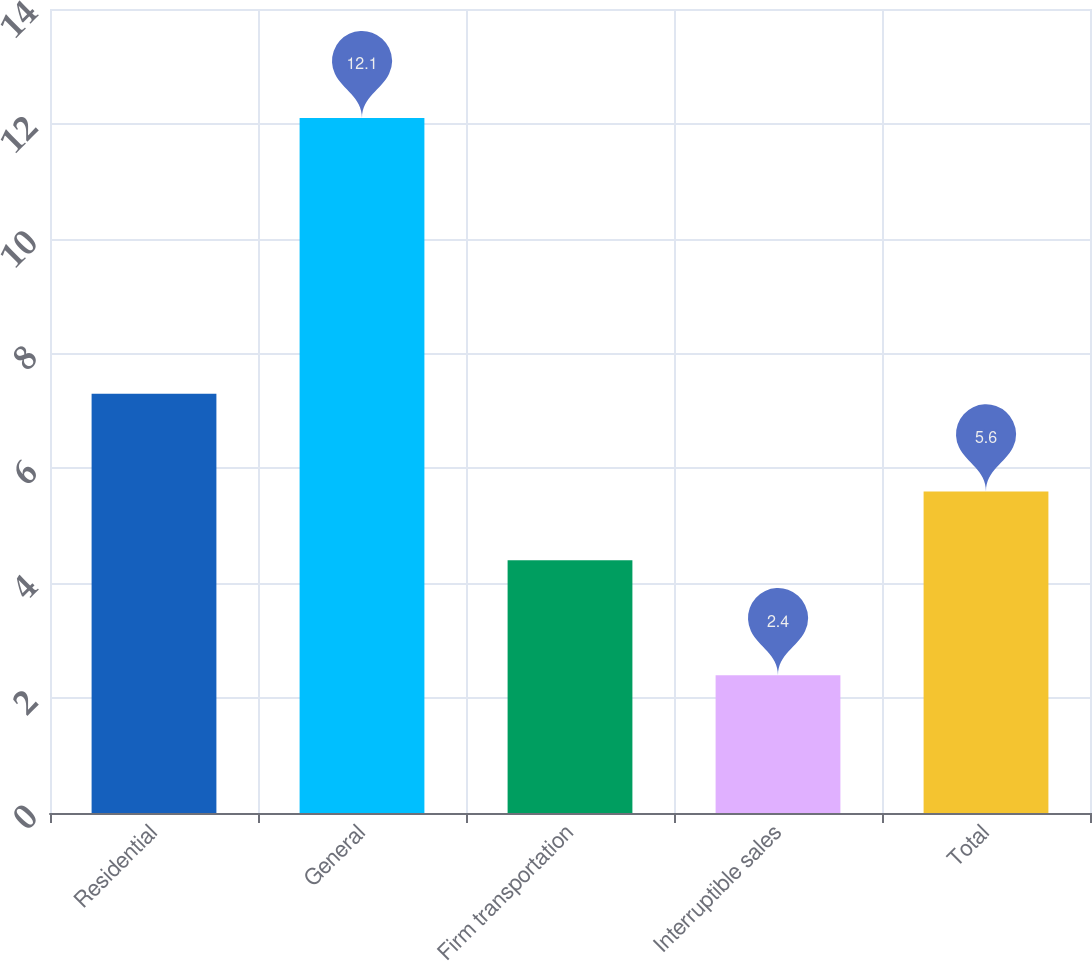Convert chart. <chart><loc_0><loc_0><loc_500><loc_500><bar_chart><fcel>Residential<fcel>General<fcel>Firm transportation<fcel>Interruptible sales<fcel>Total<nl><fcel>7.3<fcel>12.1<fcel>4.4<fcel>2.4<fcel>5.6<nl></chart> 